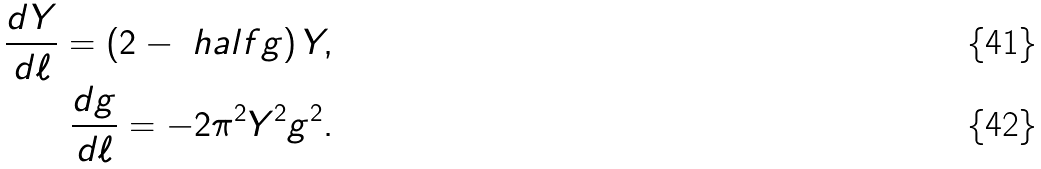<formula> <loc_0><loc_0><loc_500><loc_500>\frac { d Y } { d \ell } = \left ( 2 - \ h a l f g \right ) Y , \\ \frac { d g } { d \ell } = - 2 \pi ^ { 2 } Y ^ { 2 } g ^ { 2 } .</formula> 